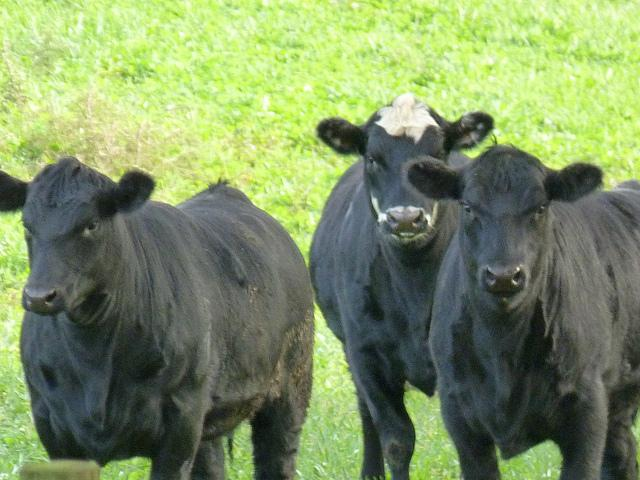What color is on the animal in the middle's head? white 